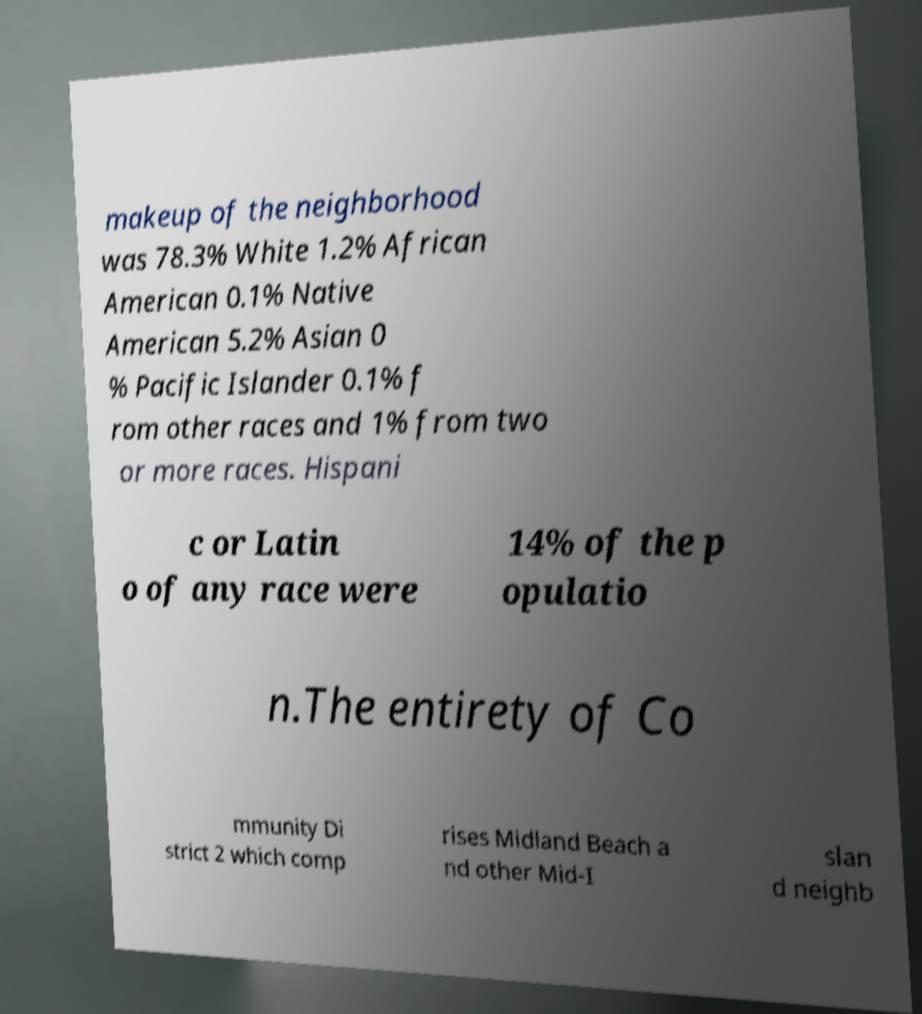I need the written content from this picture converted into text. Can you do that? makeup of the neighborhood was 78.3% White 1.2% African American 0.1% Native American 5.2% Asian 0 % Pacific Islander 0.1% f rom other races and 1% from two or more races. Hispani c or Latin o of any race were 14% of the p opulatio n.The entirety of Co mmunity Di strict 2 which comp rises Midland Beach a nd other Mid-I slan d neighb 